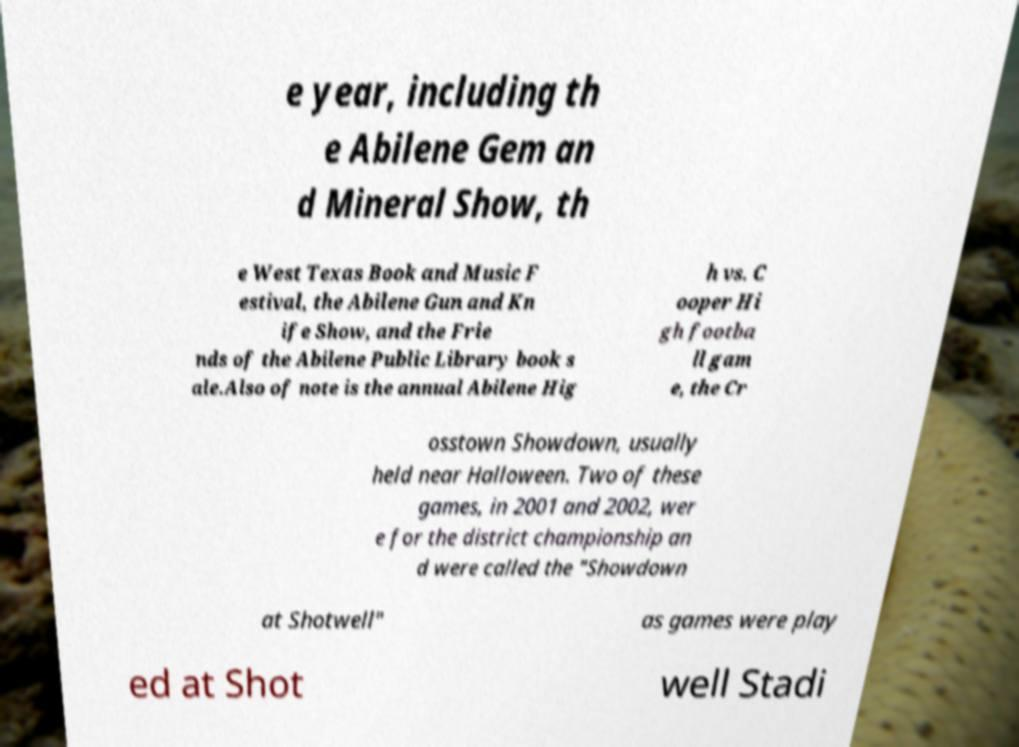Can you read and provide the text displayed in the image?This photo seems to have some interesting text. Can you extract and type it out for me? e year, including th e Abilene Gem an d Mineral Show, th e West Texas Book and Music F estival, the Abilene Gun and Kn ife Show, and the Frie nds of the Abilene Public Library book s ale.Also of note is the annual Abilene Hig h vs. C ooper Hi gh footba ll gam e, the Cr osstown Showdown, usually held near Halloween. Two of these games, in 2001 and 2002, wer e for the district championship an d were called the "Showdown at Shotwell" as games were play ed at Shot well Stadi 